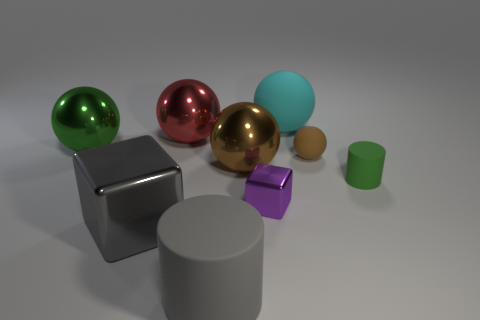Are any tiny gray metallic cylinders visible?
Make the answer very short. No. Are there any other things that are made of the same material as the tiny purple object?
Ensure brevity in your answer.  Yes. Is there a tiny object that has the same material as the large green object?
Provide a short and direct response. Yes. What is the material of the cube that is the same size as the cyan ball?
Make the answer very short. Metal. How many small brown things are the same shape as the large green thing?
Keep it short and to the point. 1. What size is the red ball that is the same material as the large block?
Your answer should be very brief. Large. What material is the object that is both in front of the tiny sphere and to the right of the cyan thing?
Keep it short and to the point. Rubber. How many brown shiny balls are the same size as the cyan sphere?
Keep it short and to the point. 1. What is the material of the small purple object that is the same shape as the large gray metal thing?
Offer a terse response. Metal. What number of objects are either large things that are to the right of the large gray matte cylinder or small objects left of the green matte object?
Provide a succinct answer. 4. 